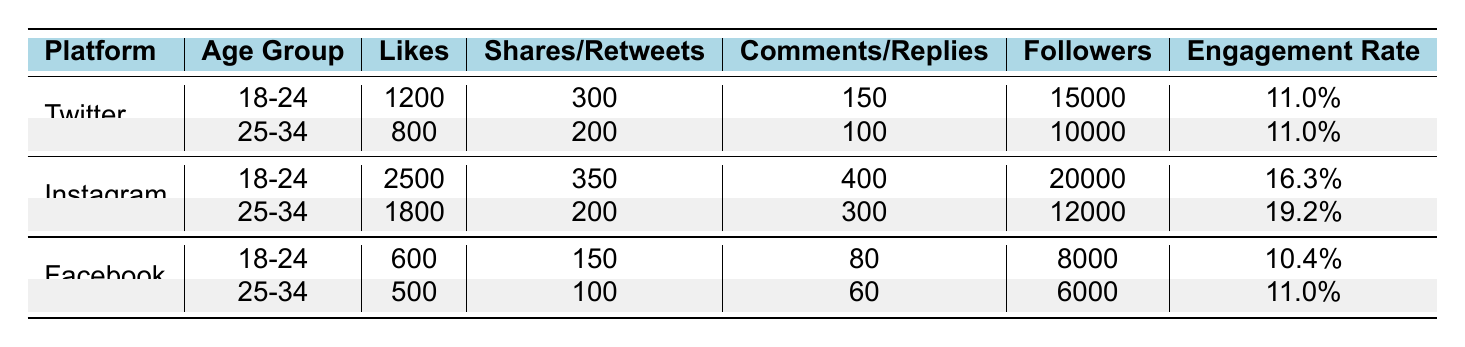What is the total number of likes for the Twitter platform? To find the total likes for Twitter, we look for both age groups under the Twitter category. The likes are 1200 for age 18-24 and 800 for age 25-34. Summing these gives us 1200 + 800 = 2000.
Answer: 2000 What is the engagement rate for the 25-34 age group on Instagram? In the table, for the 25-34 age group in Instagram, the engagement rate is listed as 19.2%.
Answer: 19.2% Is Facebook engagement rate higher than Instagram engagement rate for the 18-24 age group? For the 18-24 age group, Facebook's engagement rate is 10.4%, while Instagram's engagement rate is 16.3%. Since 10.4% is less than 16.3%, the statement is false.
Answer: No Which platform has the highest number of likes among the 18-24 age groups? Comparing the likes for each platform under the 18-24 age group: Twitter has 1200, Instagram has 2500, and Facebook has 600. The highest number is 2500 from Instagram.
Answer: Instagram What is the average number of followers for the 25-34 age group across all platforms? The followers for the 25-34 age group are 10000 (Twitter), 12000 (Instagram), and 6000 (Facebook). Adding these gives us 10000 + 12000 + 6000 = 28000. Dividing by the number of platforms (3) gives us 28000 / 3 = 9333.33.
Answer: 9333.33 Does the total number of shares for Instagram exceed the total number of shares for Twitter? For shares, Instagram has 350 (18-24) + 200 (25-34) = 550, while Twitter has 300 (18-24) + 200 (25-34) = 500. The total for Instagram is greater than Twitter. Therefore, the answer is yes.
Answer: Yes Which age group has more engagement on Facebook? For Facebook, the 18-24 age group has an engagement rate of 10.4%, while the 25-34 age group has 11.0%. The 25-34 age group has higher engagement.
Answer: 25-34 age group What is the total number of replies for both age groups in Twitter? The replies on Twitter are 150 (for age 18-24) and 100 (for age 25-34). Adding these together gives us 150 + 100 = 250.
Answer: 250 Which platform has the least likes overall? Summing the total likes: Twitter (2000), Instagram (4300), Facebook (1100) gives us 2000 + 4300 + 1100 = 7400. The smallest individual platform is Facebook with 1100 likes, making it the lowest.
Answer: Facebook 